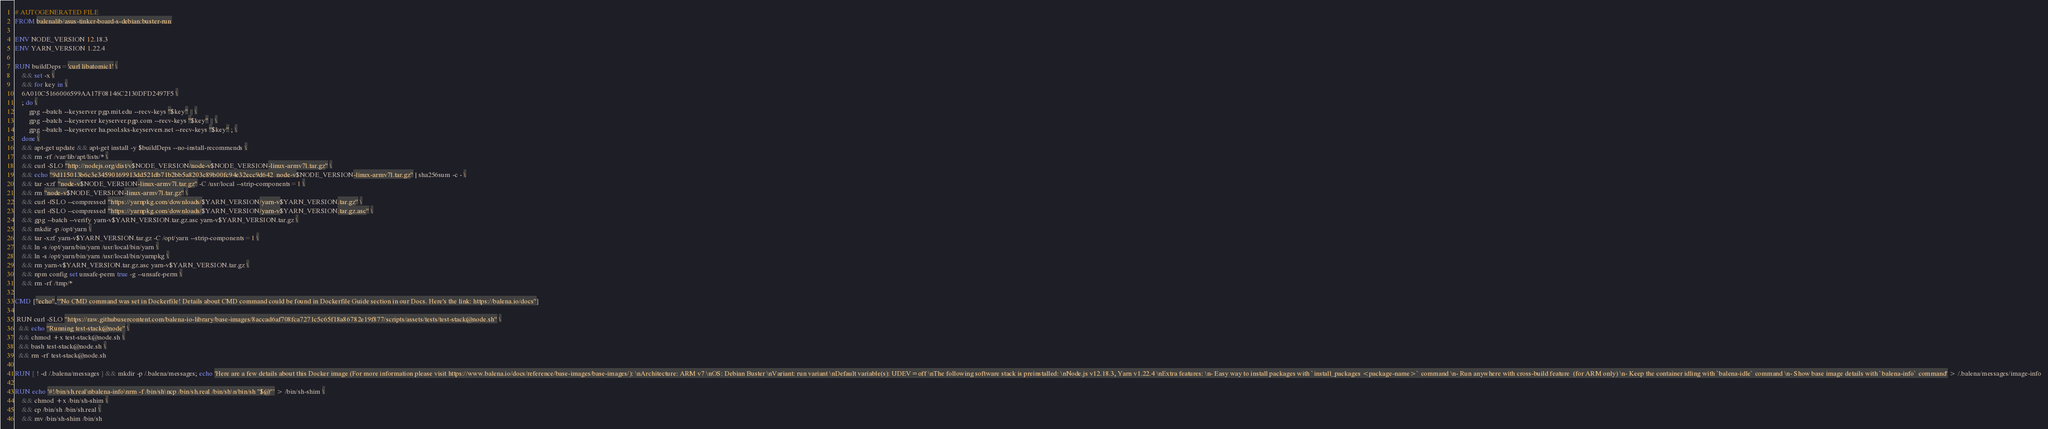Convert code to text. <code><loc_0><loc_0><loc_500><loc_500><_Dockerfile_># AUTOGENERATED FILE
FROM balenalib/asus-tinker-board-s-debian:buster-run

ENV NODE_VERSION 12.18.3
ENV YARN_VERSION 1.22.4

RUN buildDeps='curl libatomic1' \
	&& set -x \
	&& for key in \
	6A010C5166006599AA17F08146C2130DFD2497F5 \
	; do \
		gpg --batch --keyserver pgp.mit.edu --recv-keys "$key" || \
		gpg --batch --keyserver keyserver.pgp.com --recv-keys "$key" || \
		gpg --batch --keyserver ha.pool.sks-keyservers.net --recv-keys "$key" ; \
	done \
	&& apt-get update && apt-get install -y $buildDeps --no-install-recommends \
	&& rm -rf /var/lib/apt/lists/* \
	&& curl -SLO "http://nodejs.org/dist/v$NODE_VERSION/node-v$NODE_VERSION-linux-armv7l.tar.gz" \
	&& echo "9d115013b6c3e34590169913dd521db71b2bb5a8203c89b00fc94e32ecc9d642  node-v$NODE_VERSION-linux-armv7l.tar.gz" | sha256sum -c - \
	&& tar -xzf "node-v$NODE_VERSION-linux-armv7l.tar.gz" -C /usr/local --strip-components=1 \
	&& rm "node-v$NODE_VERSION-linux-armv7l.tar.gz" \
	&& curl -fSLO --compressed "https://yarnpkg.com/downloads/$YARN_VERSION/yarn-v$YARN_VERSION.tar.gz" \
	&& curl -fSLO --compressed "https://yarnpkg.com/downloads/$YARN_VERSION/yarn-v$YARN_VERSION.tar.gz.asc" \
	&& gpg --batch --verify yarn-v$YARN_VERSION.tar.gz.asc yarn-v$YARN_VERSION.tar.gz \
	&& mkdir -p /opt/yarn \
	&& tar -xzf yarn-v$YARN_VERSION.tar.gz -C /opt/yarn --strip-components=1 \
	&& ln -s /opt/yarn/bin/yarn /usr/local/bin/yarn \
	&& ln -s /opt/yarn/bin/yarn /usr/local/bin/yarnpkg \
	&& rm yarn-v$YARN_VERSION.tar.gz.asc yarn-v$YARN_VERSION.tar.gz \
	&& npm config set unsafe-perm true -g --unsafe-perm \
	&& rm -rf /tmp/*

CMD ["echo","'No CMD command was set in Dockerfile! Details about CMD command could be found in Dockerfile Guide section in our Docs. Here's the link: https://balena.io/docs"]

 RUN curl -SLO "https://raw.githubusercontent.com/balena-io-library/base-images/8accad6af708fca7271c5c65f18a86782e19f877/scripts/assets/tests/test-stack@node.sh" \
  && echo "Running test-stack@node" \
  && chmod +x test-stack@node.sh \
  && bash test-stack@node.sh \
  && rm -rf test-stack@node.sh 

RUN [ ! -d /.balena/messages ] && mkdir -p /.balena/messages; echo 'Here are a few details about this Docker image (For more information please visit https://www.balena.io/docs/reference/base-images/base-images/): \nArchitecture: ARM v7 \nOS: Debian Buster \nVariant: run variant \nDefault variable(s): UDEV=off \nThe following software stack is preinstalled: \nNode.js v12.18.3, Yarn v1.22.4 \nExtra features: \n- Easy way to install packages with `install_packages <package-name>` command \n- Run anywhere with cross-build feature  (for ARM only) \n- Keep the container idling with `balena-idle` command \n- Show base image details with `balena-info` command' > /.balena/messages/image-info

RUN echo '#!/bin/sh.real\nbalena-info\nrm -f /bin/sh\ncp /bin/sh.real /bin/sh\n/bin/sh "$@"' > /bin/sh-shim \
	&& chmod +x /bin/sh-shim \
	&& cp /bin/sh /bin/sh.real \
	&& mv /bin/sh-shim /bin/sh</code> 